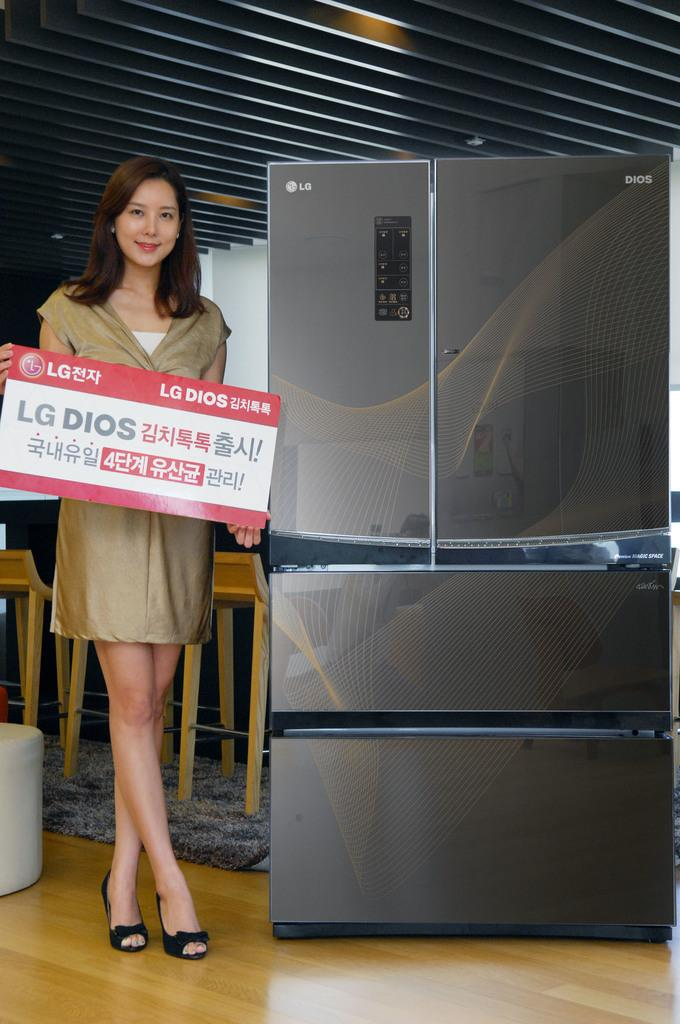<image>
Present a compact description of the photo's key features. Woman standing next to a refrigerator and holding a sign that says "LG DIOS" on it. 